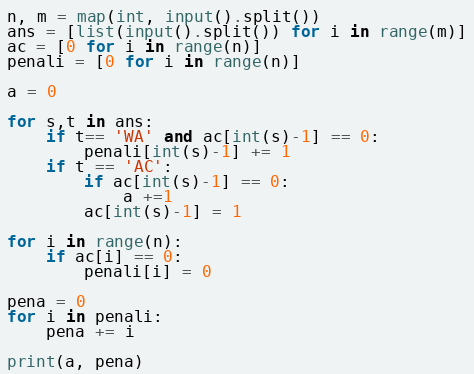<code> <loc_0><loc_0><loc_500><loc_500><_Python_>n, m = map(int, input().split())
ans = [list(input().split()) for i in range(m)]
ac = [0 for i in range(n)]
penali = [0 for i in range(n)]

a = 0

for s,t in ans:
    if t== 'WA' and ac[int(s)-1] == 0:
        penali[int(s)-1] += 1
    if t == 'AC':
        if ac[int(s)-1] == 0:
            a +=1
        ac[int(s)-1] = 1

for i in range(n):
    if ac[i] == 0:
        penali[i] = 0

pena = 0
for i in penali:
    pena += i

print(a, pena)</code> 